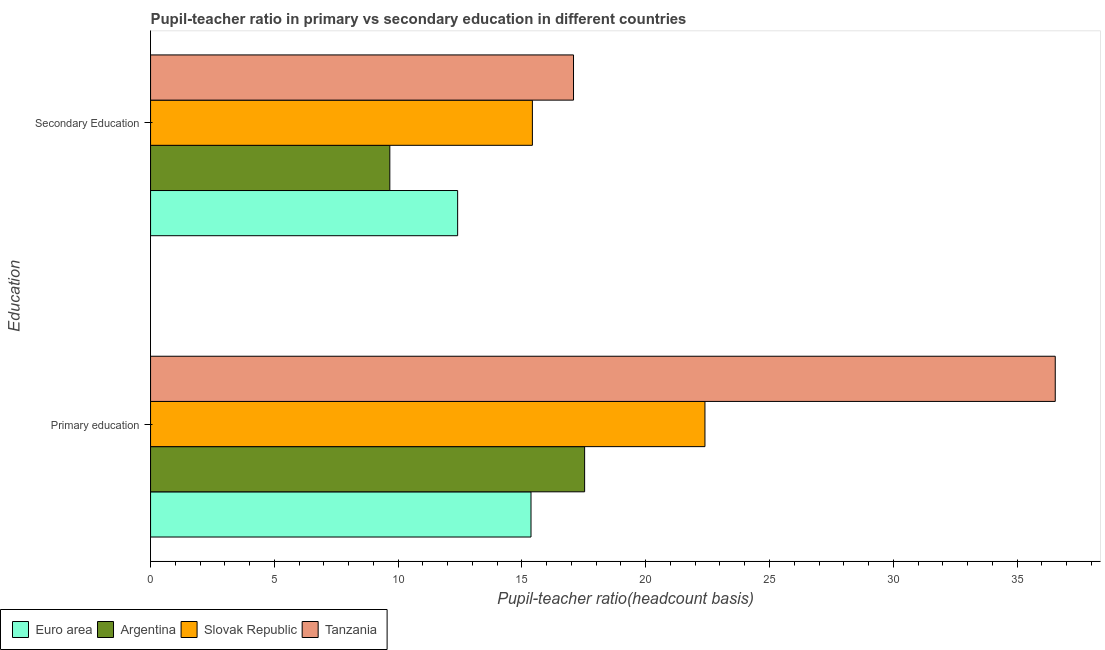How many groups of bars are there?
Provide a succinct answer. 2. Are the number of bars on each tick of the Y-axis equal?
Provide a short and direct response. Yes. How many bars are there on the 1st tick from the bottom?
Provide a succinct answer. 4. What is the label of the 1st group of bars from the top?
Give a very brief answer. Secondary Education. What is the pupil-teacher ratio in primary education in Euro area?
Provide a short and direct response. 15.37. Across all countries, what is the maximum pupil-teacher ratio in primary education?
Your answer should be very brief. 36.54. Across all countries, what is the minimum pupil teacher ratio on secondary education?
Your response must be concise. 9.66. In which country was the pupil teacher ratio on secondary education maximum?
Provide a short and direct response. Tanzania. In which country was the pupil-teacher ratio in primary education minimum?
Your response must be concise. Euro area. What is the total pupil teacher ratio on secondary education in the graph?
Your answer should be very brief. 54.58. What is the difference between the pupil-teacher ratio in primary education in Slovak Republic and that in Argentina?
Provide a short and direct response. 4.86. What is the difference between the pupil teacher ratio on secondary education in Slovak Republic and the pupil-teacher ratio in primary education in Euro area?
Ensure brevity in your answer.  0.06. What is the average pupil teacher ratio on secondary education per country?
Offer a terse response. 13.64. What is the difference between the pupil-teacher ratio in primary education and pupil teacher ratio on secondary education in Tanzania?
Keep it short and to the point. 19.46. What is the ratio of the pupil-teacher ratio in primary education in Argentina to that in Tanzania?
Make the answer very short. 0.48. Is the pupil teacher ratio on secondary education in Slovak Republic less than that in Euro area?
Make the answer very short. No. How many bars are there?
Make the answer very short. 8. Are all the bars in the graph horizontal?
Your answer should be very brief. Yes. How many countries are there in the graph?
Your answer should be very brief. 4. What is the difference between two consecutive major ticks on the X-axis?
Ensure brevity in your answer.  5. Are the values on the major ticks of X-axis written in scientific E-notation?
Ensure brevity in your answer.  No. Does the graph contain grids?
Offer a terse response. No. Where does the legend appear in the graph?
Give a very brief answer. Bottom left. How many legend labels are there?
Offer a terse response. 4. How are the legend labels stacked?
Your answer should be compact. Horizontal. What is the title of the graph?
Your answer should be very brief. Pupil-teacher ratio in primary vs secondary education in different countries. Does "High income: OECD" appear as one of the legend labels in the graph?
Your answer should be very brief. No. What is the label or title of the X-axis?
Provide a succinct answer. Pupil-teacher ratio(headcount basis). What is the label or title of the Y-axis?
Offer a very short reply. Education. What is the Pupil-teacher ratio(headcount basis) in Euro area in Primary education?
Provide a succinct answer. 15.37. What is the Pupil-teacher ratio(headcount basis) of Argentina in Primary education?
Your answer should be compact. 17.53. What is the Pupil-teacher ratio(headcount basis) in Slovak Republic in Primary education?
Give a very brief answer. 22.39. What is the Pupil-teacher ratio(headcount basis) of Tanzania in Primary education?
Keep it short and to the point. 36.54. What is the Pupil-teacher ratio(headcount basis) in Euro area in Secondary Education?
Provide a succinct answer. 12.4. What is the Pupil-teacher ratio(headcount basis) in Argentina in Secondary Education?
Offer a very short reply. 9.66. What is the Pupil-teacher ratio(headcount basis) in Slovak Republic in Secondary Education?
Ensure brevity in your answer.  15.42. What is the Pupil-teacher ratio(headcount basis) of Tanzania in Secondary Education?
Keep it short and to the point. 17.08. Across all Education, what is the maximum Pupil-teacher ratio(headcount basis) of Euro area?
Provide a short and direct response. 15.37. Across all Education, what is the maximum Pupil-teacher ratio(headcount basis) in Argentina?
Your response must be concise. 17.53. Across all Education, what is the maximum Pupil-teacher ratio(headcount basis) of Slovak Republic?
Offer a terse response. 22.39. Across all Education, what is the maximum Pupil-teacher ratio(headcount basis) of Tanzania?
Make the answer very short. 36.54. Across all Education, what is the minimum Pupil-teacher ratio(headcount basis) in Euro area?
Your answer should be very brief. 12.4. Across all Education, what is the minimum Pupil-teacher ratio(headcount basis) of Argentina?
Make the answer very short. 9.66. Across all Education, what is the minimum Pupil-teacher ratio(headcount basis) in Slovak Republic?
Your response must be concise. 15.42. Across all Education, what is the minimum Pupil-teacher ratio(headcount basis) in Tanzania?
Your answer should be very brief. 17.08. What is the total Pupil-teacher ratio(headcount basis) of Euro area in the graph?
Provide a succinct answer. 27.77. What is the total Pupil-teacher ratio(headcount basis) in Argentina in the graph?
Provide a succinct answer. 27.2. What is the total Pupil-teacher ratio(headcount basis) in Slovak Republic in the graph?
Keep it short and to the point. 37.82. What is the total Pupil-teacher ratio(headcount basis) of Tanzania in the graph?
Keep it short and to the point. 53.63. What is the difference between the Pupil-teacher ratio(headcount basis) of Euro area in Primary education and that in Secondary Education?
Keep it short and to the point. 2.96. What is the difference between the Pupil-teacher ratio(headcount basis) of Argentina in Primary education and that in Secondary Education?
Provide a short and direct response. 7.87. What is the difference between the Pupil-teacher ratio(headcount basis) in Slovak Republic in Primary education and that in Secondary Education?
Your response must be concise. 6.97. What is the difference between the Pupil-teacher ratio(headcount basis) in Tanzania in Primary education and that in Secondary Education?
Make the answer very short. 19.46. What is the difference between the Pupil-teacher ratio(headcount basis) in Euro area in Primary education and the Pupil-teacher ratio(headcount basis) in Argentina in Secondary Education?
Ensure brevity in your answer.  5.7. What is the difference between the Pupil-teacher ratio(headcount basis) of Euro area in Primary education and the Pupil-teacher ratio(headcount basis) of Slovak Republic in Secondary Education?
Offer a very short reply. -0.06. What is the difference between the Pupil-teacher ratio(headcount basis) of Euro area in Primary education and the Pupil-teacher ratio(headcount basis) of Tanzania in Secondary Education?
Your answer should be very brief. -1.72. What is the difference between the Pupil-teacher ratio(headcount basis) in Argentina in Primary education and the Pupil-teacher ratio(headcount basis) in Slovak Republic in Secondary Education?
Your response must be concise. 2.11. What is the difference between the Pupil-teacher ratio(headcount basis) in Argentina in Primary education and the Pupil-teacher ratio(headcount basis) in Tanzania in Secondary Education?
Your response must be concise. 0.45. What is the difference between the Pupil-teacher ratio(headcount basis) in Slovak Republic in Primary education and the Pupil-teacher ratio(headcount basis) in Tanzania in Secondary Education?
Your answer should be compact. 5.31. What is the average Pupil-teacher ratio(headcount basis) of Euro area per Education?
Your answer should be compact. 13.89. What is the average Pupil-teacher ratio(headcount basis) in Argentina per Education?
Your answer should be very brief. 13.6. What is the average Pupil-teacher ratio(headcount basis) of Slovak Republic per Education?
Provide a succinct answer. 18.91. What is the average Pupil-teacher ratio(headcount basis) in Tanzania per Education?
Offer a very short reply. 26.81. What is the difference between the Pupil-teacher ratio(headcount basis) in Euro area and Pupil-teacher ratio(headcount basis) in Argentina in Primary education?
Offer a terse response. -2.17. What is the difference between the Pupil-teacher ratio(headcount basis) of Euro area and Pupil-teacher ratio(headcount basis) of Slovak Republic in Primary education?
Provide a succinct answer. -7.03. What is the difference between the Pupil-teacher ratio(headcount basis) in Euro area and Pupil-teacher ratio(headcount basis) in Tanzania in Primary education?
Your answer should be very brief. -21.18. What is the difference between the Pupil-teacher ratio(headcount basis) in Argentina and Pupil-teacher ratio(headcount basis) in Slovak Republic in Primary education?
Offer a very short reply. -4.86. What is the difference between the Pupil-teacher ratio(headcount basis) of Argentina and Pupil-teacher ratio(headcount basis) of Tanzania in Primary education?
Offer a terse response. -19.01. What is the difference between the Pupil-teacher ratio(headcount basis) in Slovak Republic and Pupil-teacher ratio(headcount basis) in Tanzania in Primary education?
Offer a very short reply. -14.15. What is the difference between the Pupil-teacher ratio(headcount basis) of Euro area and Pupil-teacher ratio(headcount basis) of Argentina in Secondary Education?
Offer a very short reply. 2.74. What is the difference between the Pupil-teacher ratio(headcount basis) in Euro area and Pupil-teacher ratio(headcount basis) in Slovak Republic in Secondary Education?
Make the answer very short. -3.02. What is the difference between the Pupil-teacher ratio(headcount basis) of Euro area and Pupil-teacher ratio(headcount basis) of Tanzania in Secondary Education?
Your answer should be very brief. -4.68. What is the difference between the Pupil-teacher ratio(headcount basis) of Argentina and Pupil-teacher ratio(headcount basis) of Slovak Republic in Secondary Education?
Provide a short and direct response. -5.76. What is the difference between the Pupil-teacher ratio(headcount basis) of Argentina and Pupil-teacher ratio(headcount basis) of Tanzania in Secondary Education?
Keep it short and to the point. -7.42. What is the difference between the Pupil-teacher ratio(headcount basis) of Slovak Republic and Pupil-teacher ratio(headcount basis) of Tanzania in Secondary Education?
Provide a short and direct response. -1.66. What is the ratio of the Pupil-teacher ratio(headcount basis) of Euro area in Primary education to that in Secondary Education?
Your response must be concise. 1.24. What is the ratio of the Pupil-teacher ratio(headcount basis) of Argentina in Primary education to that in Secondary Education?
Give a very brief answer. 1.81. What is the ratio of the Pupil-teacher ratio(headcount basis) in Slovak Republic in Primary education to that in Secondary Education?
Ensure brevity in your answer.  1.45. What is the ratio of the Pupil-teacher ratio(headcount basis) in Tanzania in Primary education to that in Secondary Education?
Your response must be concise. 2.14. What is the difference between the highest and the second highest Pupil-teacher ratio(headcount basis) in Euro area?
Ensure brevity in your answer.  2.96. What is the difference between the highest and the second highest Pupil-teacher ratio(headcount basis) of Argentina?
Your answer should be very brief. 7.87. What is the difference between the highest and the second highest Pupil-teacher ratio(headcount basis) in Slovak Republic?
Your response must be concise. 6.97. What is the difference between the highest and the second highest Pupil-teacher ratio(headcount basis) in Tanzania?
Your answer should be very brief. 19.46. What is the difference between the highest and the lowest Pupil-teacher ratio(headcount basis) in Euro area?
Provide a short and direct response. 2.96. What is the difference between the highest and the lowest Pupil-teacher ratio(headcount basis) in Argentina?
Your response must be concise. 7.87. What is the difference between the highest and the lowest Pupil-teacher ratio(headcount basis) of Slovak Republic?
Keep it short and to the point. 6.97. What is the difference between the highest and the lowest Pupil-teacher ratio(headcount basis) in Tanzania?
Ensure brevity in your answer.  19.46. 